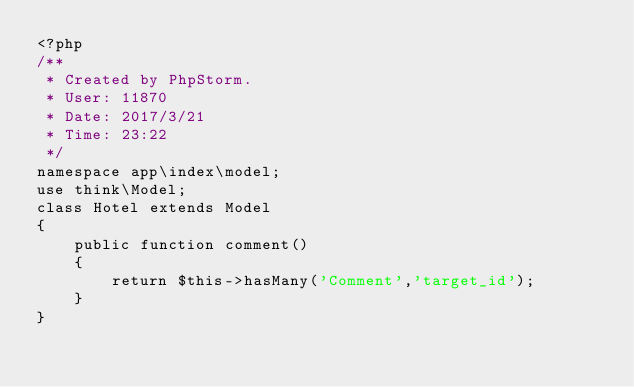<code> <loc_0><loc_0><loc_500><loc_500><_PHP_><?php
/**
 * Created by PhpStorm.
 * User: 11870
 * Date: 2017/3/21
 * Time: 23:22
 */
namespace app\index\model;
use think\Model;
class Hotel extends Model
{
    public function comment()
    {
        return $this->hasMany('Comment','target_id');
    }
}</code> 